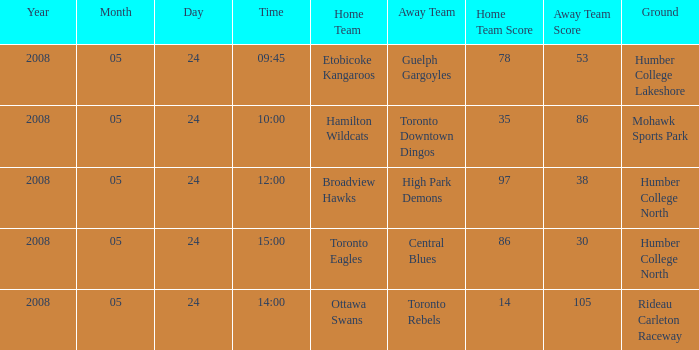On what day was the game that ended in a score of 97-38? 2008-05-24. 